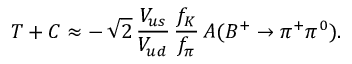Convert formula to latex. <formula><loc_0><loc_0><loc_500><loc_500>T + C \approx - \, \sqrt { 2 } \, \frac { V _ { u s } } { V _ { u d } } \, \frac { f _ { K } } { f _ { \pi } } \, A ( B ^ { + } \to \pi ^ { + } \pi ^ { 0 } ) .</formula> 